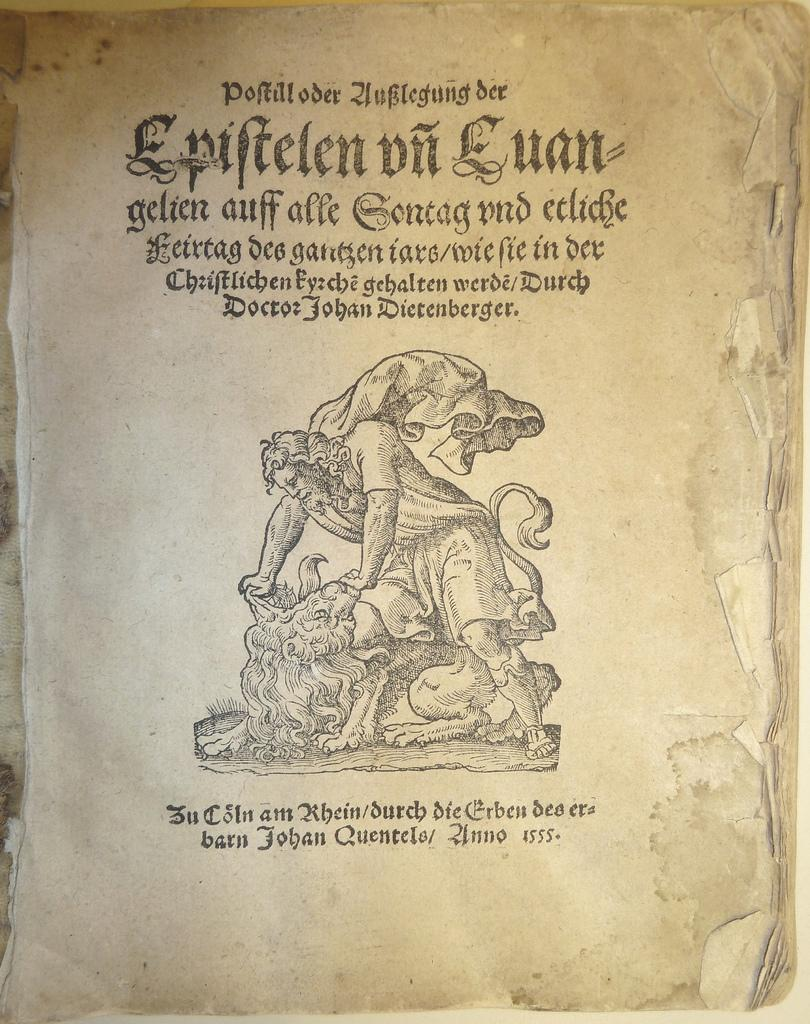<image>
Provide a brief description of the given image. The old book was written some time around the 16th century 